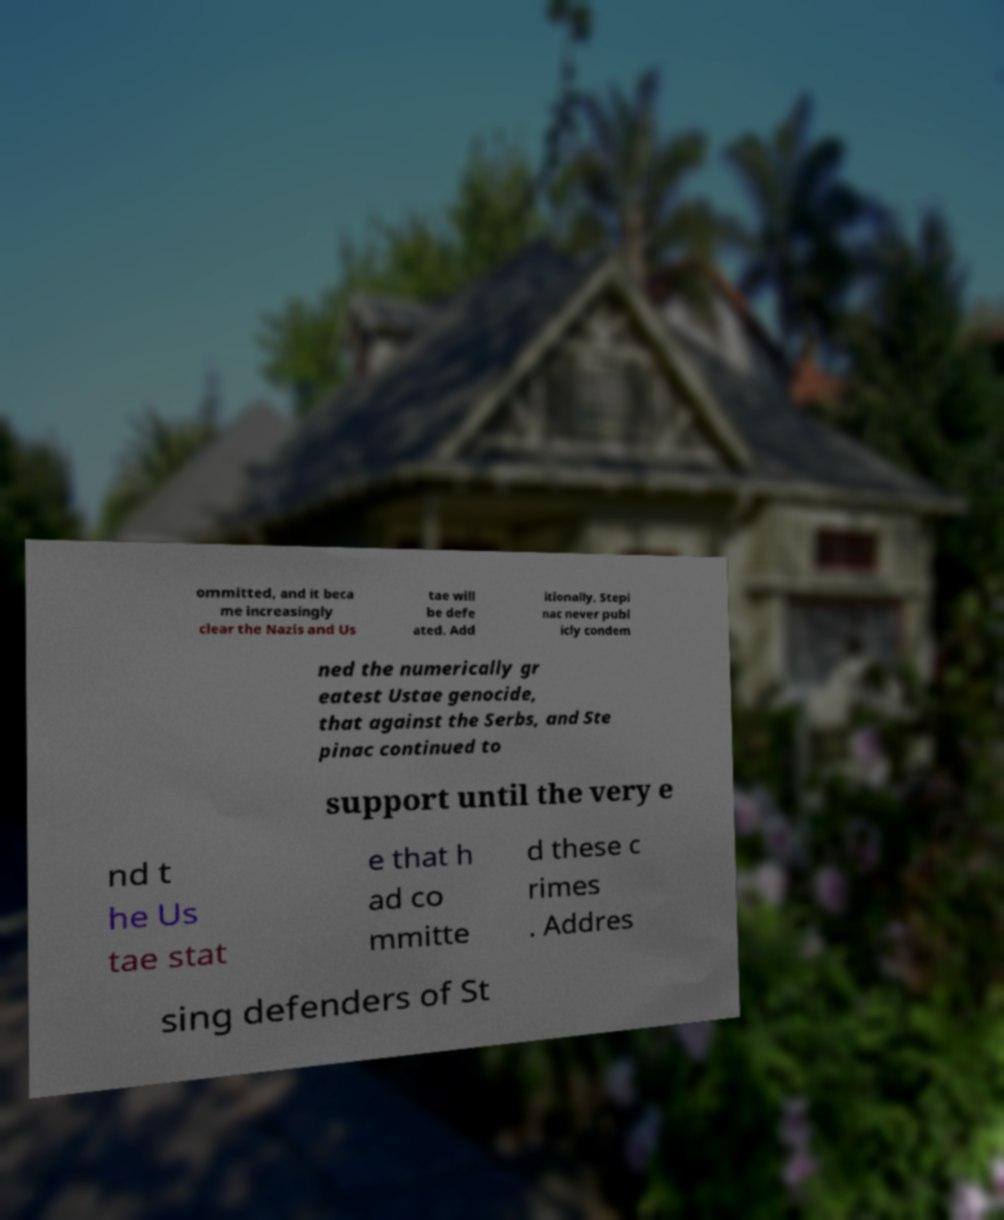Please read and relay the text visible in this image. What does it say? ommitted, and it beca me increasingly clear the Nazis and Us tae will be defe ated. Add itionally, Stepi nac never publ icly condem ned the numerically gr eatest Ustae genocide, that against the Serbs, and Ste pinac continued to support until the very e nd t he Us tae stat e that h ad co mmitte d these c rimes . Addres sing defenders of St 